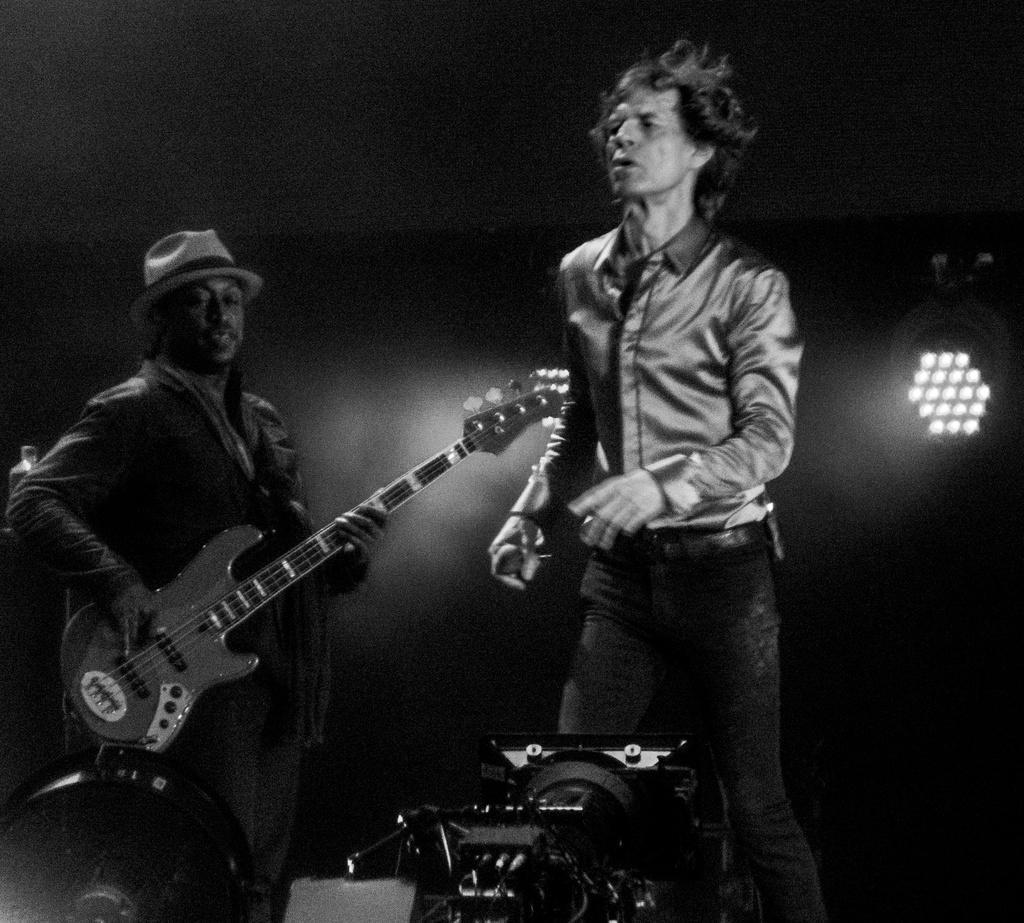In one or two sentences, can you explain what this image depicts? This is a black and white picture. Here we can see two persons. He is playing guitar and he wear a cap. And this is light. 